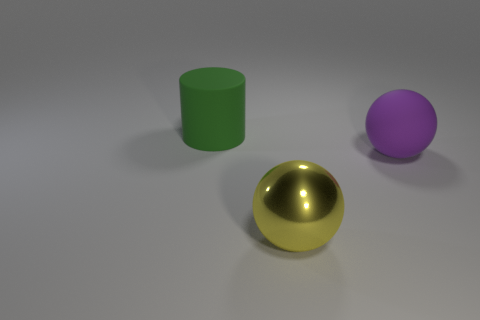Add 1 gray matte cubes. How many objects exist? 4 Subtract all yellow spheres. How many spheres are left? 1 Subtract 0 gray balls. How many objects are left? 3 Subtract all cylinders. How many objects are left? 2 Subtract 2 balls. How many balls are left? 0 Subtract all green spheres. Subtract all green cylinders. How many spheres are left? 2 Subtract all green cylinders. How many yellow spheres are left? 1 Subtract all cylinders. Subtract all big spheres. How many objects are left? 0 Add 3 big purple spheres. How many big purple spheres are left? 4 Add 3 red objects. How many red objects exist? 3 